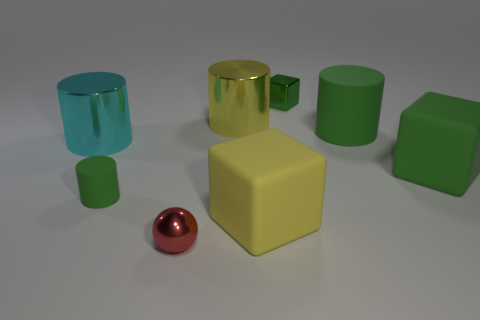There is a yellow object that is right of the yellow thing behind the large yellow rubber block; what size is it?
Ensure brevity in your answer.  Large. There is a cyan object; what shape is it?
Ensure brevity in your answer.  Cylinder. There is a green cylinder left of the large green cylinder; what is its material?
Make the answer very short. Rubber. There is a rubber block in front of the small green thing in front of the yellow thing behind the cyan object; what color is it?
Offer a very short reply. Yellow. The metal thing that is the same size as the cyan metallic cylinder is what color?
Your response must be concise. Yellow. What number of rubber things are either tiny things or small brown cylinders?
Make the answer very short. 1. There is a sphere that is made of the same material as the small green cube; what is its color?
Offer a terse response. Red. There is a big cube right of the yellow block that is in front of the tiny shiny block; what is its material?
Offer a very short reply. Rubber. How many objects are green cubes behind the cyan metal cylinder or things that are right of the red shiny ball?
Provide a short and direct response. 5. There is a green rubber cylinder left of the small metal object in front of the green thing on the left side of the small green shiny thing; what size is it?
Keep it short and to the point. Small. 